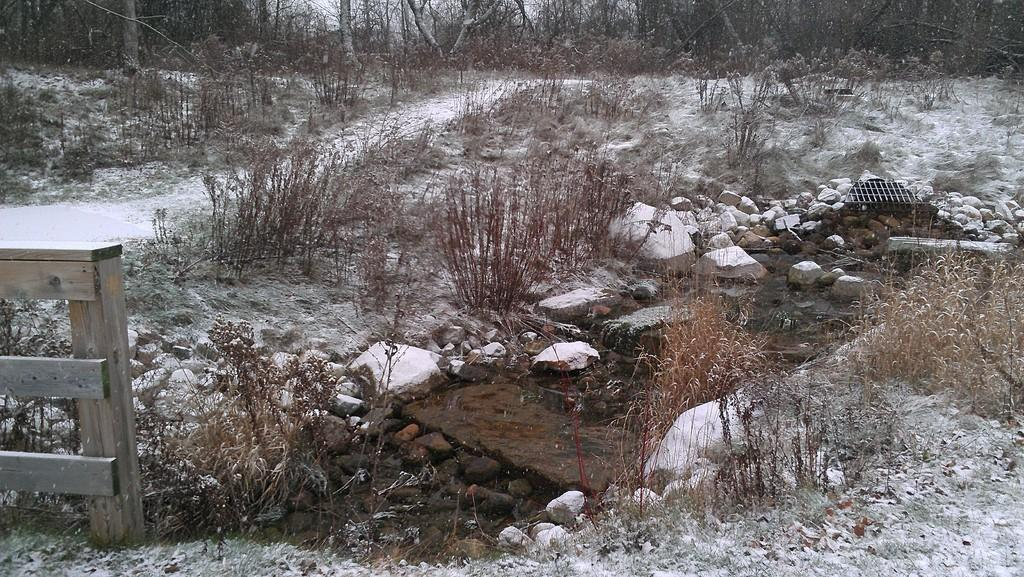What type of structure is visible in the image? There is a fencing in the image. What natural elements can be seen in the image? There are rocks, stones, and plants visible in the image. What type of insect can be seen learning to write prose in the image? There is no insect present in the image, and insects do not learn to write prose. 